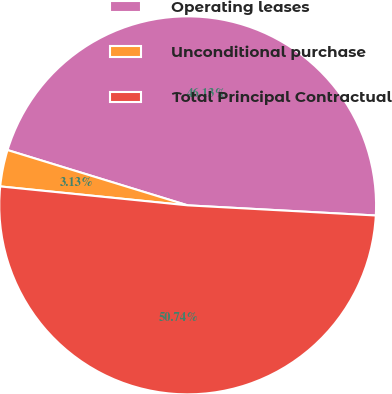Convert chart to OTSL. <chart><loc_0><loc_0><loc_500><loc_500><pie_chart><fcel>Operating leases<fcel>Unconditional purchase<fcel>Total Principal Contractual<nl><fcel>46.13%<fcel>3.13%<fcel>50.74%<nl></chart> 